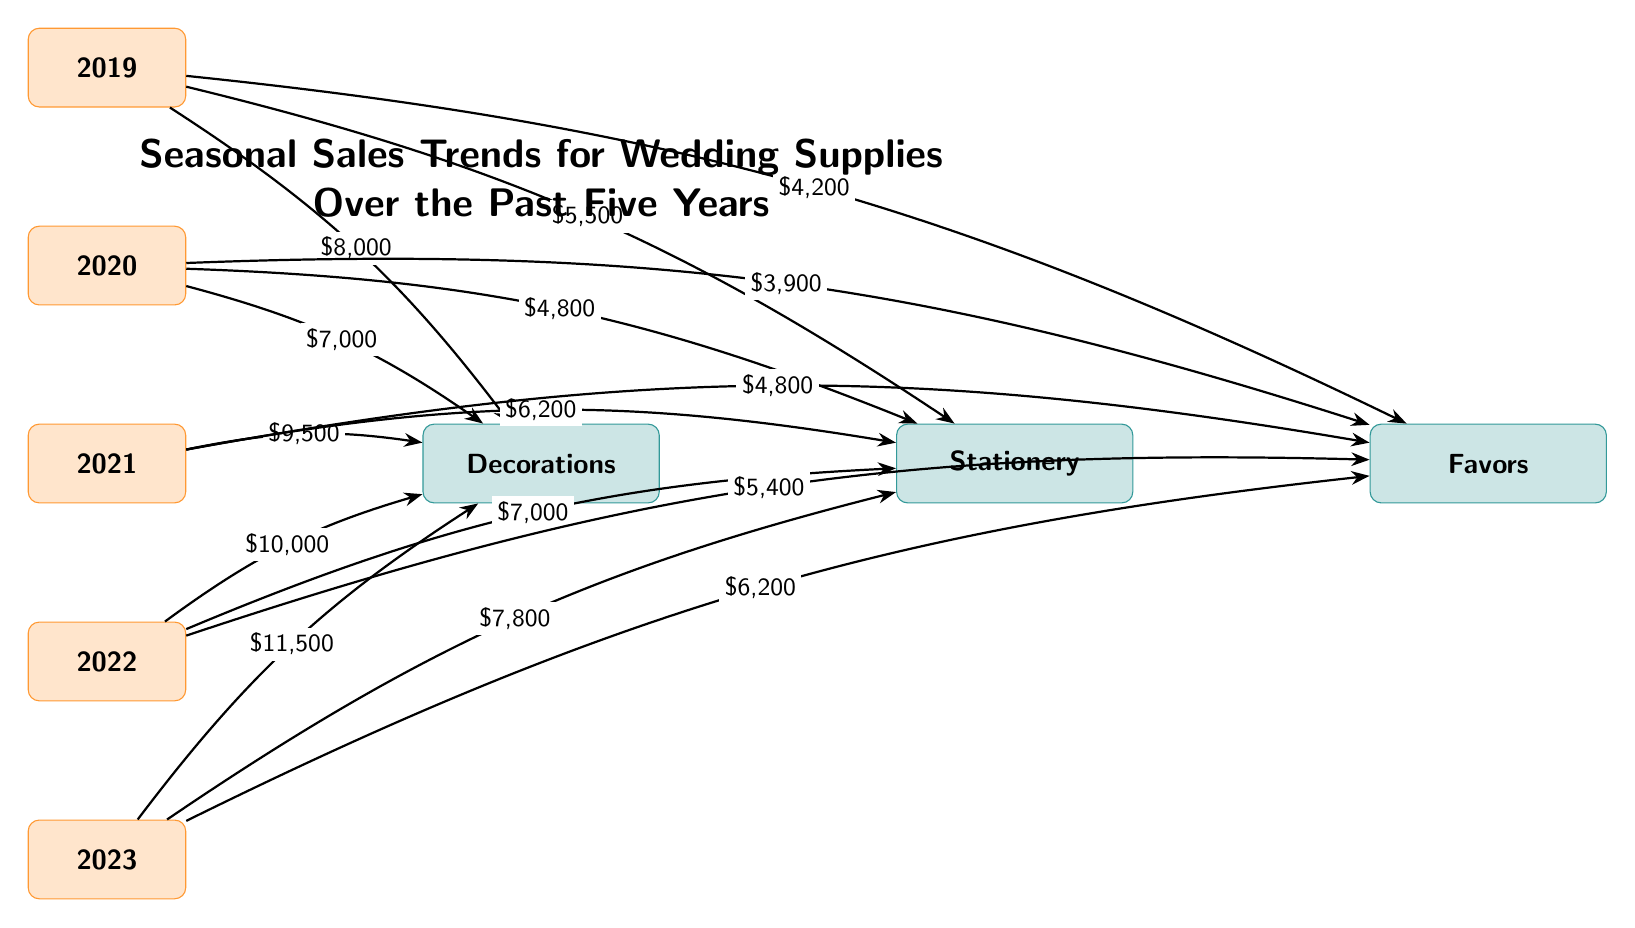What was the sales amount for decorations in 2021? The diagram indicates that the sales amount for decorations in 2021 is represented by an arrow leading to the "Decorations" category from the year "2021," which shows a label of $9,500.
Answer: $9,500 Which product category had the lowest sales in 2020? To find the lowest sales in 2020, we check the amounts for each product category connected to the year "2020." Decorations had $7,000, stationery had $4,800, and favors had $3,900. Among these, favors had the lowest sales figure of $3,900.
Answer: Favors What trend can be observed for the sales of stationery from 2019 to 2023? By examining the sales figures for stationery from each year (2019: $5,500, 2020: $4,800, 2021: $6,200, 2022: $7,000, 2023: $7,800), we can see that the sales fluctuated initially but showed an overall increasing trend from a low in 2020 to a high in 2023.
Answer: Increasing How much did favors sales increase from 2020 to 2021? To calculate the increase in favors sales from 2020 to 2021, we subtract the 2020 sales amount ($3,900) from the 2021 sales amount ($4,800). Therefore, $4,800 - $3,900 = $900 increase.
Answer: $900 Which year had the highest sales for decorations? The year with the highest sales for decorations can be identified by comparing the sales figures across all years for the "Decorations" category. From the diagram, 2023 showed the highest sales figure of $11,500.
Answer: 2023 What is the total sales amount for all categories in 2022? To find the total sales amount for all categories in 2022, we add the sales figures for decorations ($10,000), stationery ($7,000), and favors ($5,400). Calculating this gives us $10,000 + $7,000 + $5,400 = $22,400.
Answer: $22,400 How do the sales of favors in 2023 compare to those in 2022? Comparing the sales figures, favors had $5,400 in 2022 and $6,200 in 2023. By performing a comparison, we can see that favors increased from 2022 to 2023, as $6,200 is greater than $5,400.
Answer: Increased What was the sales amount for stationery in 2023? The diagram shows that the sales amount for stationery in 2023 is represented by an arrow leading to the "Stationery" category from the year "2023," which has a label of $7,800.
Answer: $7,800 